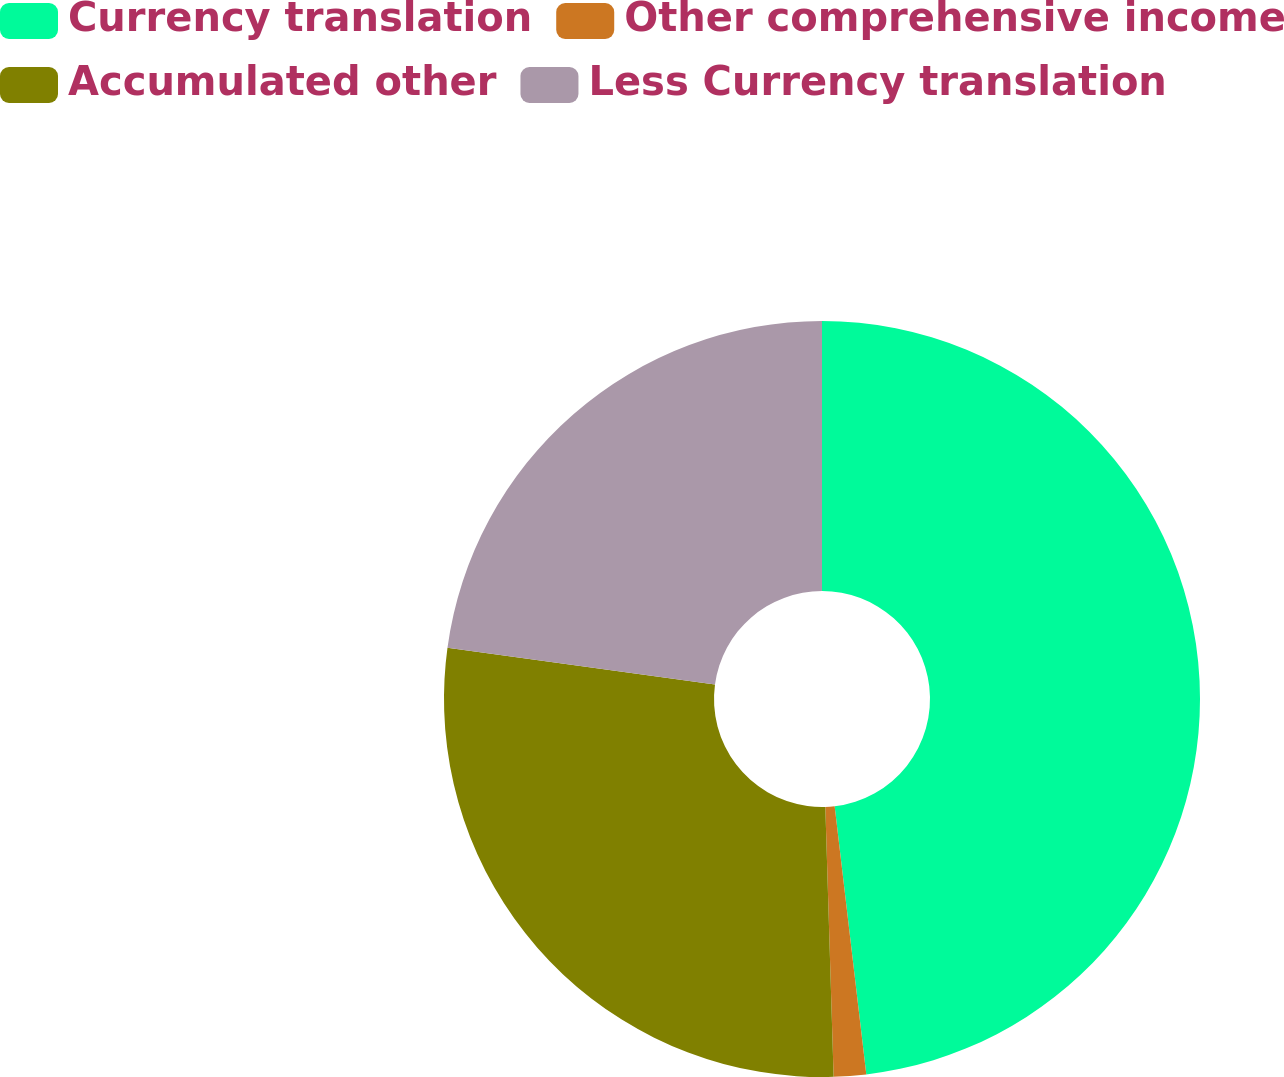Convert chart to OTSL. <chart><loc_0><loc_0><loc_500><loc_500><pie_chart><fcel>Currency translation<fcel>Other comprehensive income<fcel>Accumulated other<fcel>Less Currency translation<nl><fcel>48.13%<fcel>1.38%<fcel>27.65%<fcel>22.84%<nl></chart> 